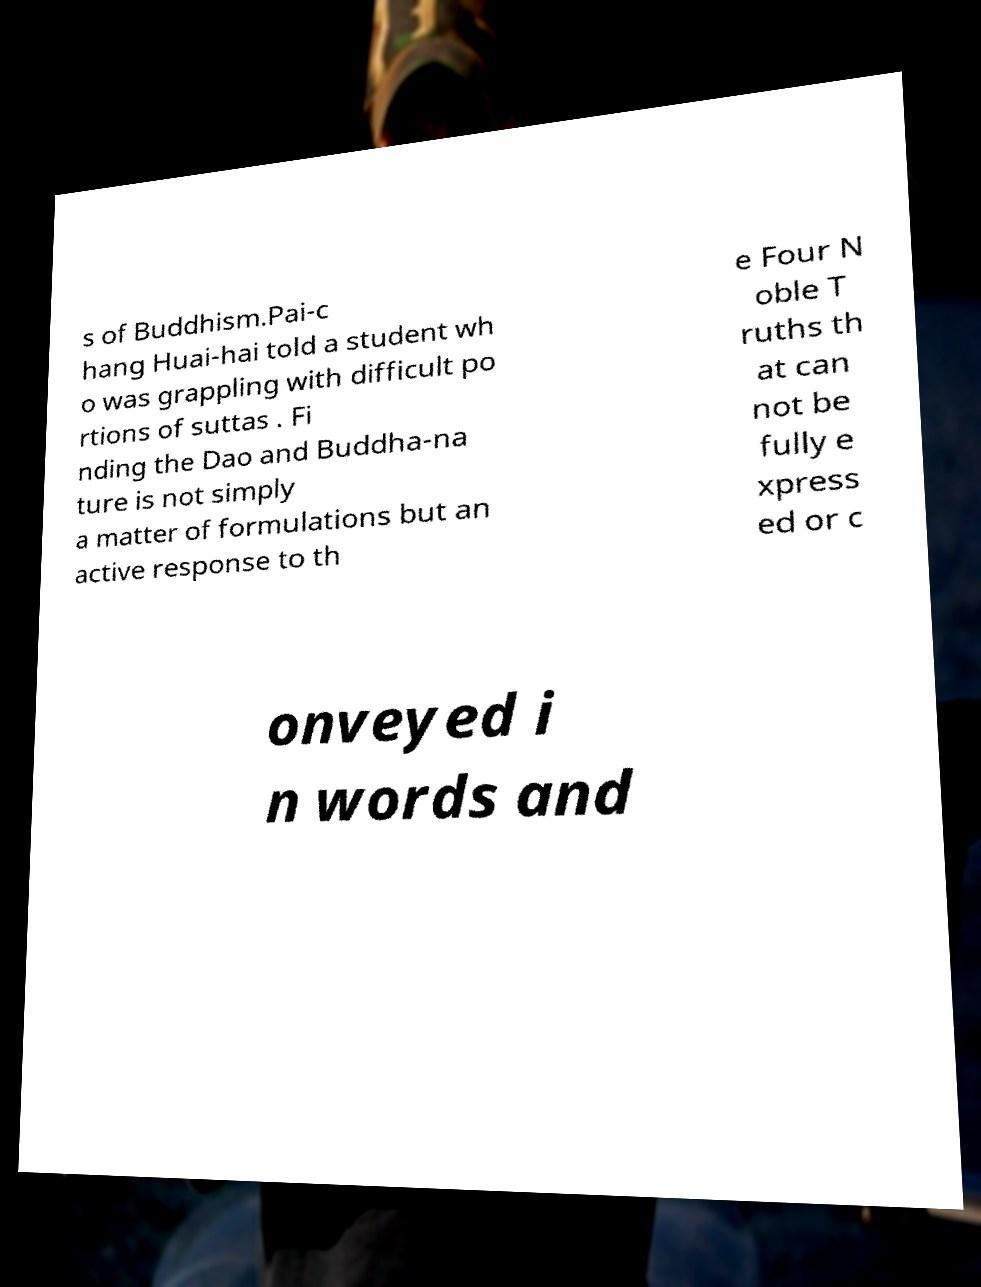I need the written content from this picture converted into text. Can you do that? s of Buddhism.Pai-c hang Huai-hai told a student wh o was grappling with difficult po rtions of suttas . Fi nding the Dao and Buddha-na ture is not simply a matter of formulations but an active response to th e Four N oble T ruths th at can not be fully e xpress ed or c onveyed i n words and 